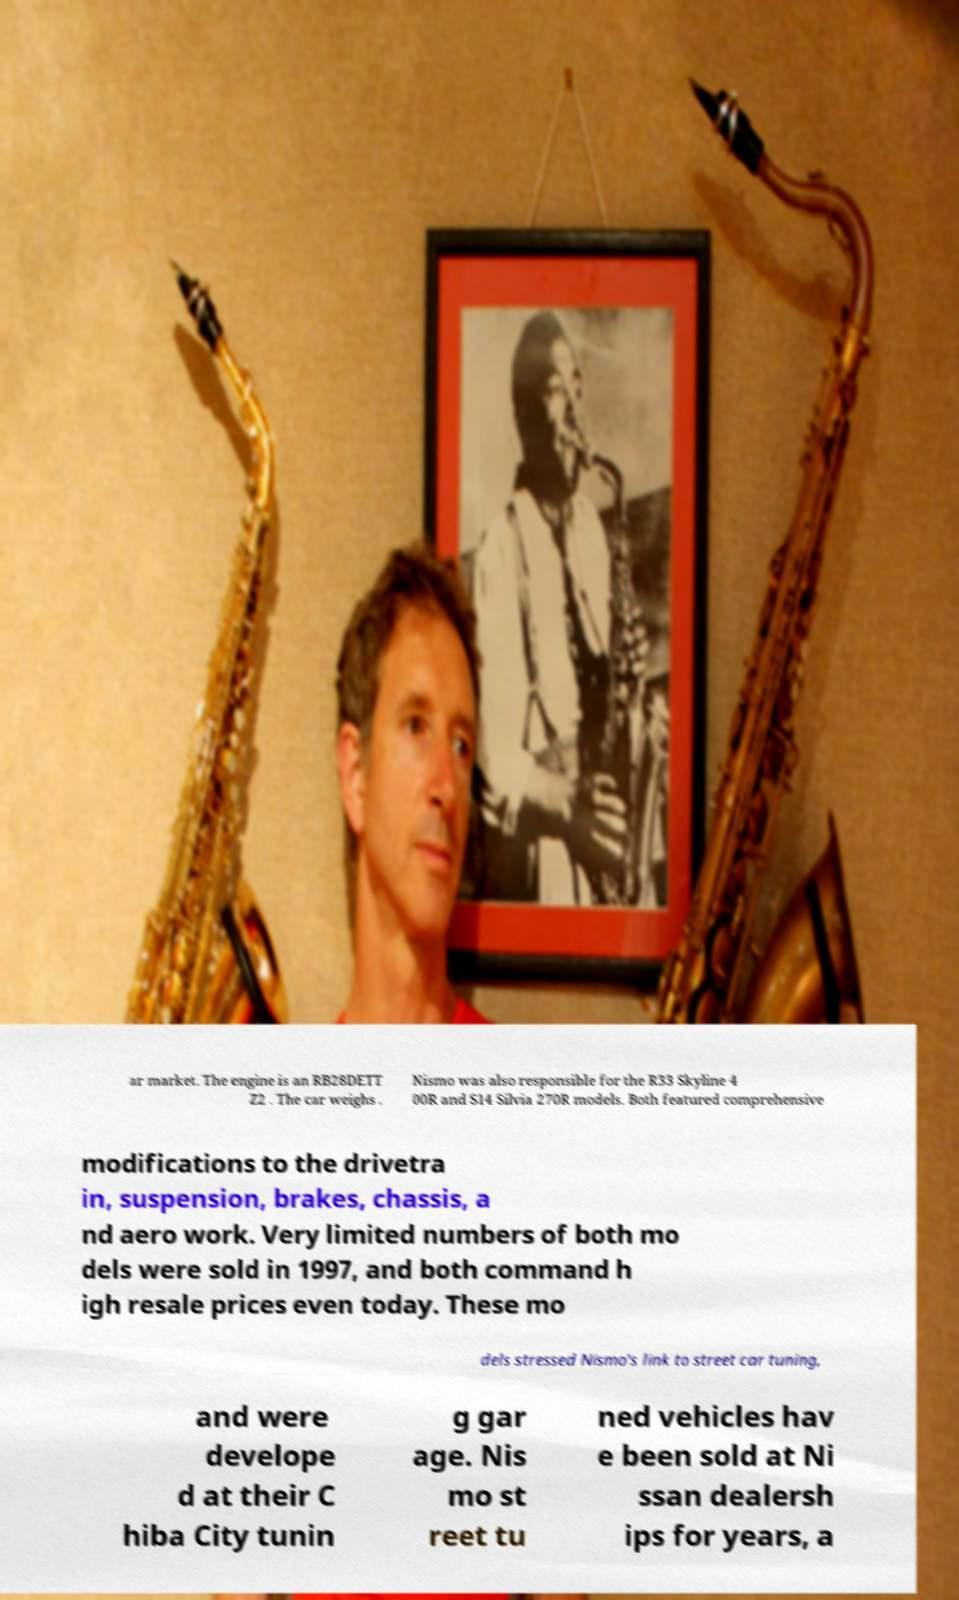Could you assist in decoding the text presented in this image and type it out clearly? ar market. The engine is an RB28DETT Z2 . The car weighs . Nismo was also responsible for the R33 Skyline 4 00R and S14 Silvia 270R models. Both featured comprehensive modifications to the drivetra in, suspension, brakes, chassis, a nd aero work. Very limited numbers of both mo dels were sold in 1997, and both command h igh resale prices even today. These mo dels stressed Nismo's link to street car tuning, and were develope d at their C hiba City tunin g gar age. Nis mo st reet tu ned vehicles hav e been sold at Ni ssan dealersh ips for years, a 